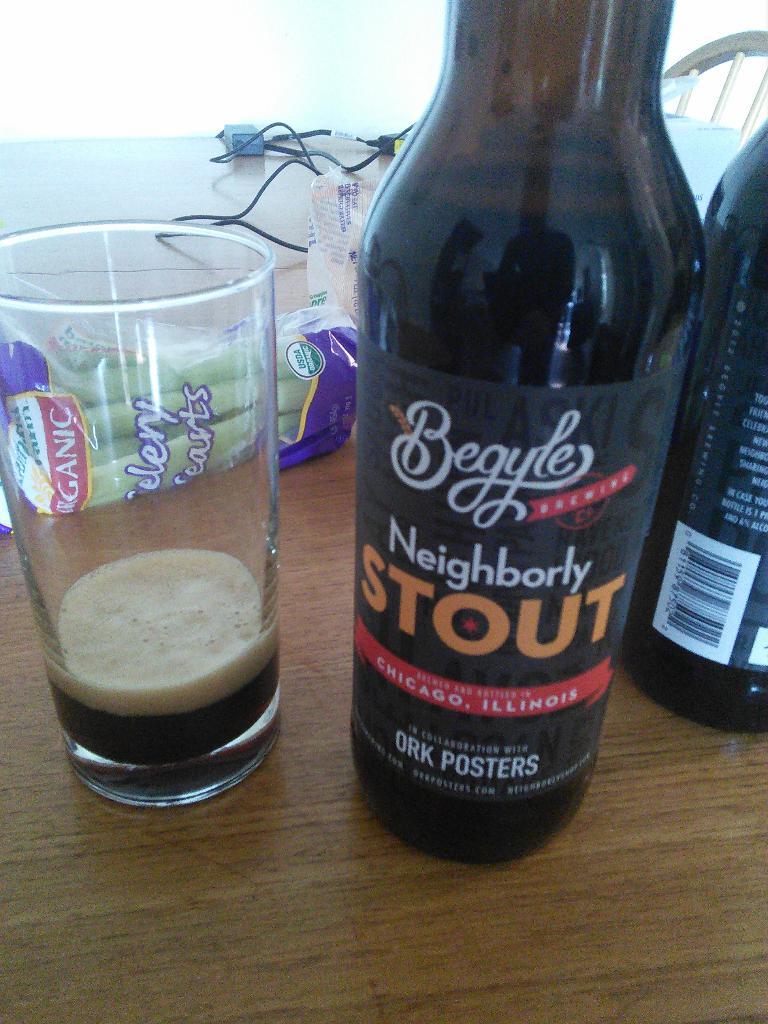What does it say at the bottem of this bottle?
Your answer should be very brief. Ork posters. What is the brand of this beer?
Provide a short and direct response. Begyle. 